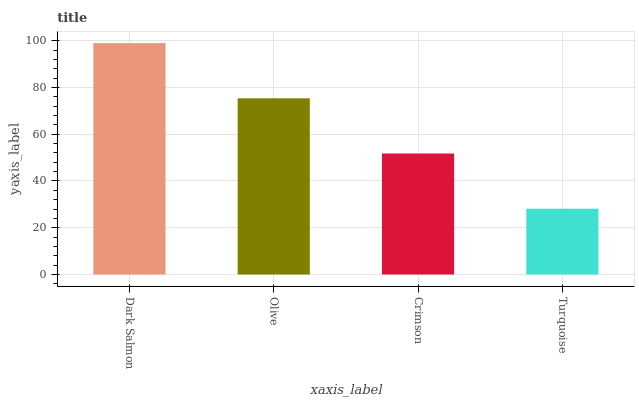Is Turquoise the minimum?
Answer yes or no. Yes. Is Dark Salmon the maximum?
Answer yes or no. Yes. Is Olive the minimum?
Answer yes or no. No. Is Olive the maximum?
Answer yes or no. No. Is Dark Salmon greater than Olive?
Answer yes or no. Yes. Is Olive less than Dark Salmon?
Answer yes or no. Yes. Is Olive greater than Dark Salmon?
Answer yes or no. No. Is Dark Salmon less than Olive?
Answer yes or no. No. Is Olive the high median?
Answer yes or no. Yes. Is Crimson the low median?
Answer yes or no. Yes. Is Turquoise the high median?
Answer yes or no. No. Is Turquoise the low median?
Answer yes or no. No. 